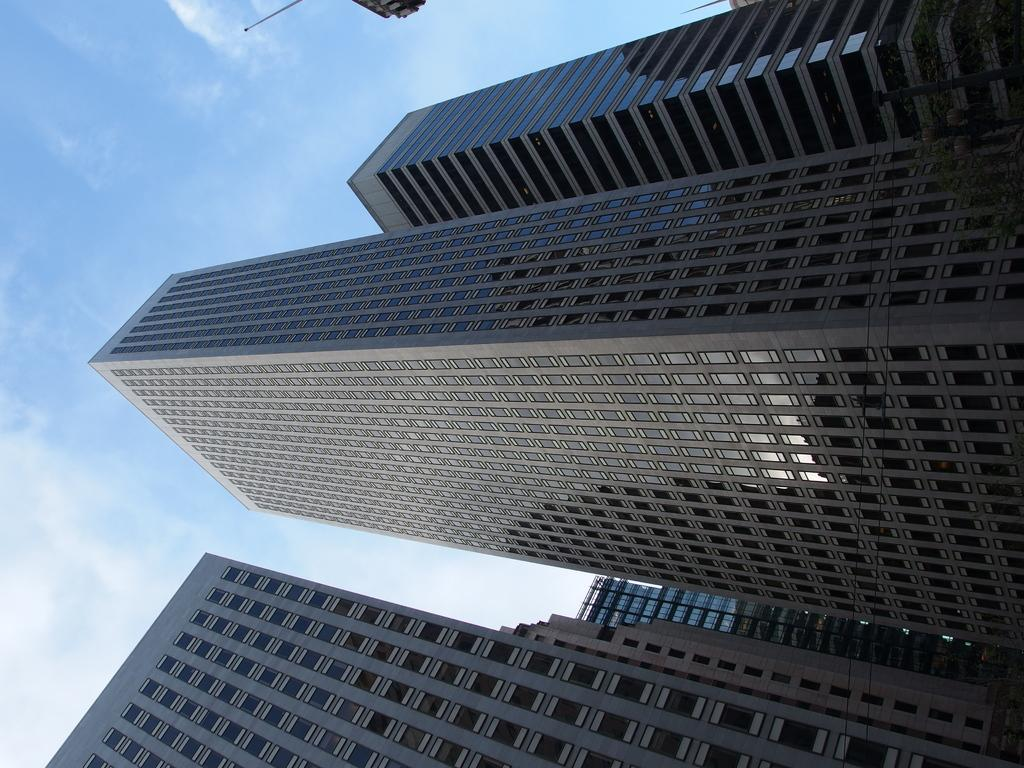What type of structures can be seen in the image? There are buildings in the image. What part of the natural environment is visible in the image? The sky is visible in the image. What can be seen in the sky? Clouds are present in the sky. What type of furniture can be seen in the image? There is no furniture present in the image; it features buildings and clouds in the sky. Can you tell me the hour at which the image was taken? The provided facts do not include information about the time of day or hour, so it cannot be determined from the image. 